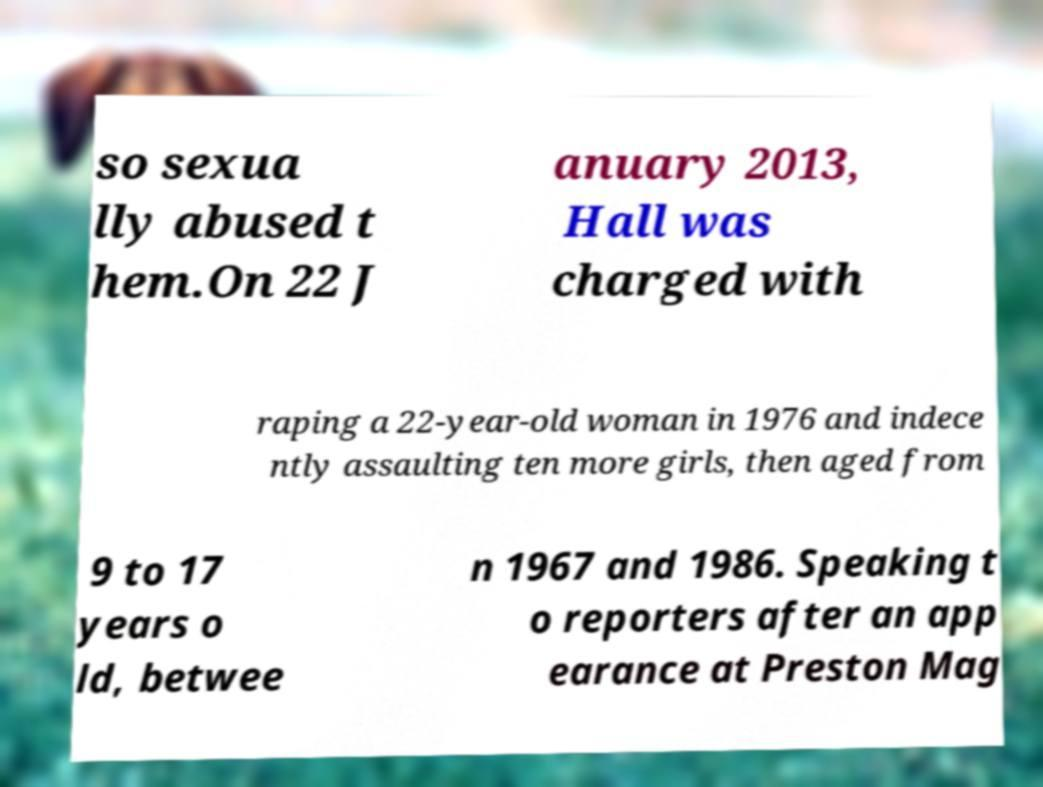I need the written content from this picture converted into text. Can you do that? so sexua lly abused t hem.On 22 J anuary 2013, Hall was charged with raping a 22-year-old woman in 1976 and indece ntly assaulting ten more girls, then aged from 9 to 17 years o ld, betwee n 1967 and 1986. Speaking t o reporters after an app earance at Preston Mag 